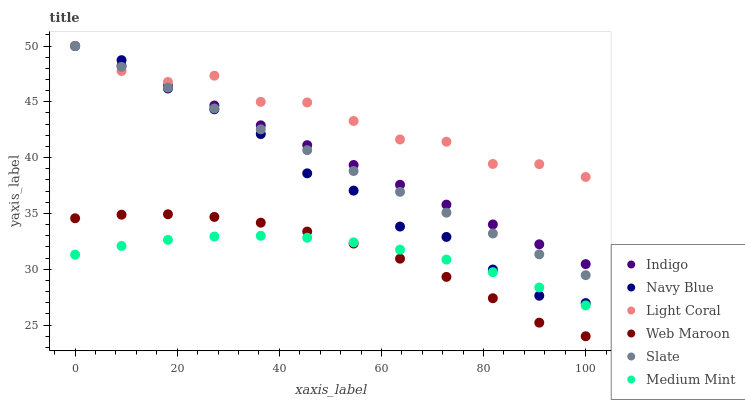Does Medium Mint have the minimum area under the curve?
Answer yes or no. Yes. Does Light Coral have the maximum area under the curve?
Answer yes or no. Yes. Does Indigo have the minimum area under the curve?
Answer yes or no. No. Does Indigo have the maximum area under the curve?
Answer yes or no. No. Is Indigo the smoothest?
Answer yes or no. Yes. Is Light Coral the roughest?
Answer yes or no. Yes. Is Navy Blue the smoothest?
Answer yes or no. No. Is Navy Blue the roughest?
Answer yes or no. No. Does Web Maroon have the lowest value?
Answer yes or no. Yes. Does Indigo have the lowest value?
Answer yes or no. No. Does Light Coral have the highest value?
Answer yes or no. Yes. Does Web Maroon have the highest value?
Answer yes or no. No. Is Medium Mint less than Slate?
Answer yes or no. Yes. Is Navy Blue greater than Web Maroon?
Answer yes or no. Yes. Does Medium Mint intersect Navy Blue?
Answer yes or no. Yes. Is Medium Mint less than Navy Blue?
Answer yes or no. No. Is Medium Mint greater than Navy Blue?
Answer yes or no. No. Does Medium Mint intersect Slate?
Answer yes or no. No. 